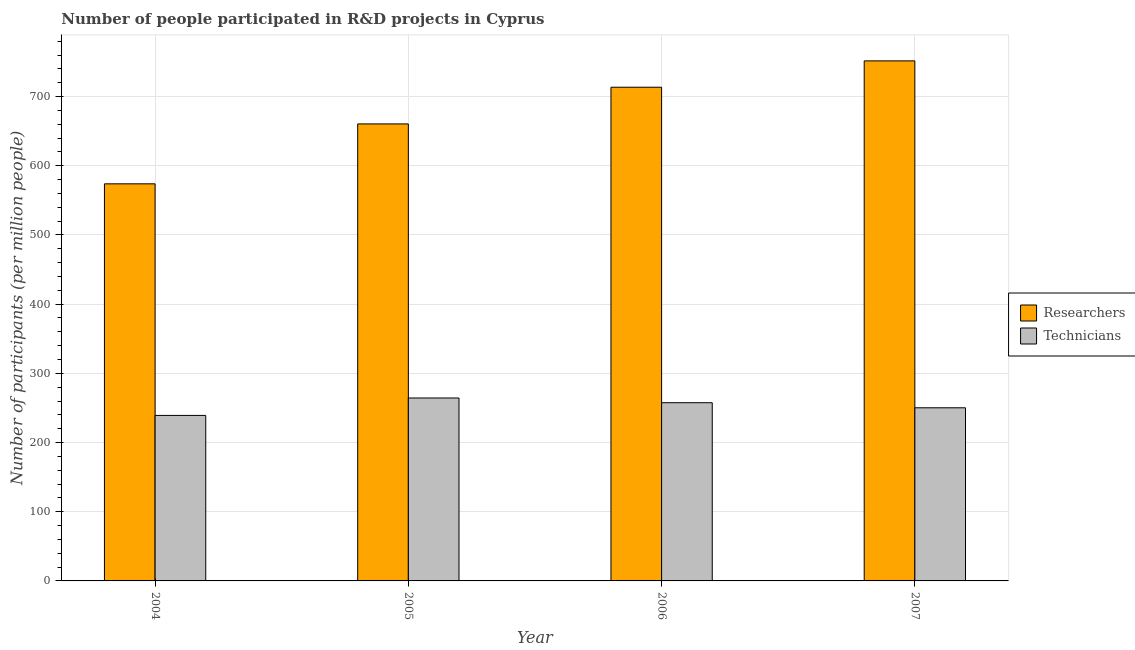How many groups of bars are there?
Give a very brief answer. 4. Are the number of bars on each tick of the X-axis equal?
Ensure brevity in your answer.  Yes. How many bars are there on the 2nd tick from the left?
Offer a very short reply. 2. How many bars are there on the 3rd tick from the right?
Offer a very short reply. 2. What is the number of researchers in 2006?
Offer a terse response. 713.54. Across all years, what is the maximum number of researchers?
Your answer should be compact. 751.62. Across all years, what is the minimum number of technicians?
Your answer should be compact. 239.21. In which year was the number of researchers maximum?
Offer a terse response. 2007. In which year was the number of researchers minimum?
Make the answer very short. 2004. What is the total number of researchers in the graph?
Make the answer very short. 2699.55. What is the difference between the number of technicians in 2004 and that in 2005?
Provide a succinct answer. -25.17. What is the difference between the number of technicians in 2005 and the number of researchers in 2007?
Give a very brief answer. 14.16. What is the average number of technicians per year?
Give a very brief answer. 252.85. What is the ratio of the number of technicians in 2006 to that in 2007?
Your answer should be very brief. 1.03. Is the difference between the number of technicians in 2005 and 2006 greater than the difference between the number of researchers in 2005 and 2006?
Provide a short and direct response. No. What is the difference between the highest and the second highest number of technicians?
Provide a succinct answer. 6.82. What is the difference between the highest and the lowest number of technicians?
Make the answer very short. 25.17. In how many years, is the number of technicians greater than the average number of technicians taken over all years?
Provide a succinct answer. 2. What does the 1st bar from the left in 2005 represents?
Give a very brief answer. Researchers. What does the 2nd bar from the right in 2005 represents?
Your answer should be compact. Researchers. Are the values on the major ticks of Y-axis written in scientific E-notation?
Keep it short and to the point. No. Does the graph contain any zero values?
Your response must be concise. No. Does the graph contain grids?
Make the answer very short. Yes. How many legend labels are there?
Your response must be concise. 2. What is the title of the graph?
Your answer should be compact. Number of people participated in R&D projects in Cyprus. Does "Register a property" appear as one of the legend labels in the graph?
Offer a very short reply. No. What is the label or title of the X-axis?
Offer a very short reply. Year. What is the label or title of the Y-axis?
Make the answer very short. Number of participants (per million people). What is the Number of participants (per million people) in Researchers in 2004?
Provide a succinct answer. 573.92. What is the Number of participants (per million people) in Technicians in 2004?
Keep it short and to the point. 239.21. What is the Number of participants (per million people) of Researchers in 2005?
Provide a succinct answer. 660.48. What is the Number of participants (per million people) in Technicians in 2005?
Give a very brief answer. 264.38. What is the Number of participants (per million people) in Researchers in 2006?
Your response must be concise. 713.54. What is the Number of participants (per million people) in Technicians in 2006?
Provide a short and direct response. 257.56. What is the Number of participants (per million people) of Researchers in 2007?
Make the answer very short. 751.62. What is the Number of participants (per million people) of Technicians in 2007?
Your answer should be very brief. 250.23. Across all years, what is the maximum Number of participants (per million people) of Researchers?
Ensure brevity in your answer.  751.62. Across all years, what is the maximum Number of participants (per million people) in Technicians?
Offer a terse response. 264.38. Across all years, what is the minimum Number of participants (per million people) of Researchers?
Provide a short and direct response. 573.92. Across all years, what is the minimum Number of participants (per million people) of Technicians?
Offer a terse response. 239.21. What is the total Number of participants (per million people) of Researchers in the graph?
Provide a succinct answer. 2699.55. What is the total Number of participants (per million people) in Technicians in the graph?
Ensure brevity in your answer.  1011.39. What is the difference between the Number of participants (per million people) of Researchers in 2004 and that in 2005?
Your response must be concise. -86.56. What is the difference between the Number of participants (per million people) in Technicians in 2004 and that in 2005?
Give a very brief answer. -25.17. What is the difference between the Number of participants (per million people) in Researchers in 2004 and that in 2006?
Your answer should be very brief. -139.62. What is the difference between the Number of participants (per million people) in Technicians in 2004 and that in 2006?
Keep it short and to the point. -18.35. What is the difference between the Number of participants (per million people) in Researchers in 2004 and that in 2007?
Offer a terse response. -177.7. What is the difference between the Number of participants (per million people) in Technicians in 2004 and that in 2007?
Offer a terse response. -11.01. What is the difference between the Number of participants (per million people) of Researchers in 2005 and that in 2006?
Your response must be concise. -53.06. What is the difference between the Number of participants (per million people) of Technicians in 2005 and that in 2006?
Provide a succinct answer. 6.82. What is the difference between the Number of participants (per million people) in Researchers in 2005 and that in 2007?
Offer a terse response. -91.14. What is the difference between the Number of participants (per million people) in Technicians in 2005 and that in 2007?
Your answer should be compact. 14.16. What is the difference between the Number of participants (per million people) in Researchers in 2006 and that in 2007?
Your answer should be very brief. -38.08. What is the difference between the Number of participants (per million people) of Technicians in 2006 and that in 2007?
Your answer should be compact. 7.34. What is the difference between the Number of participants (per million people) in Researchers in 2004 and the Number of participants (per million people) in Technicians in 2005?
Keep it short and to the point. 309.53. What is the difference between the Number of participants (per million people) in Researchers in 2004 and the Number of participants (per million people) in Technicians in 2006?
Your response must be concise. 316.36. What is the difference between the Number of participants (per million people) in Researchers in 2004 and the Number of participants (per million people) in Technicians in 2007?
Your response must be concise. 323.69. What is the difference between the Number of participants (per million people) in Researchers in 2005 and the Number of participants (per million people) in Technicians in 2006?
Ensure brevity in your answer.  402.92. What is the difference between the Number of participants (per million people) in Researchers in 2005 and the Number of participants (per million people) in Technicians in 2007?
Your answer should be compact. 410.25. What is the difference between the Number of participants (per million people) of Researchers in 2006 and the Number of participants (per million people) of Technicians in 2007?
Provide a short and direct response. 463.32. What is the average Number of participants (per million people) of Researchers per year?
Provide a short and direct response. 674.89. What is the average Number of participants (per million people) in Technicians per year?
Your answer should be very brief. 252.85. In the year 2004, what is the difference between the Number of participants (per million people) of Researchers and Number of participants (per million people) of Technicians?
Offer a terse response. 334.7. In the year 2005, what is the difference between the Number of participants (per million people) in Researchers and Number of participants (per million people) in Technicians?
Ensure brevity in your answer.  396.09. In the year 2006, what is the difference between the Number of participants (per million people) in Researchers and Number of participants (per million people) in Technicians?
Your answer should be compact. 455.98. In the year 2007, what is the difference between the Number of participants (per million people) of Researchers and Number of participants (per million people) of Technicians?
Offer a very short reply. 501.39. What is the ratio of the Number of participants (per million people) in Researchers in 2004 to that in 2005?
Offer a very short reply. 0.87. What is the ratio of the Number of participants (per million people) in Technicians in 2004 to that in 2005?
Make the answer very short. 0.9. What is the ratio of the Number of participants (per million people) in Researchers in 2004 to that in 2006?
Ensure brevity in your answer.  0.8. What is the ratio of the Number of participants (per million people) in Technicians in 2004 to that in 2006?
Provide a short and direct response. 0.93. What is the ratio of the Number of participants (per million people) of Researchers in 2004 to that in 2007?
Keep it short and to the point. 0.76. What is the ratio of the Number of participants (per million people) of Technicians in 2004 to that in 2007?
Keep it short and to the point. 0.96. What is the ratio of the Number of participants (per million people) in Researchers in 2005 to that in 2006?
Your answer should be very brief. 0.93. What is the ratio of the Number of participants (per million people) in Technicians in 2005 to that in 2006?
Provide a succinct answer. 1.03. What is the ratio of the Number of participants (per million people) in Researchers in 2005 to that in 2007?
Ensure brevity in your answer.  0.88. What is the ratio of the Number of participants (per million people) of Technicians in 2005 to that in 2007?
Give a very brief answer. 1.06. What is the ratio of the Number of participants (per million people) of Researchers in 2006 to that in 2007?
Give a very brief answer. 0.95. What is the ratio of the Number of participants (per million people) in Technicians in 2006 to that in 2007?
Offer a very short reply. 1.03. What is the difference between the highest and the second highest Number of participants (per million people) of Researchers?
Give a very brief answer. 38.08. What is the difference between the highest and the second highest Number of participants (per million people) in Technicians?
Give a very brief answer. 6.82. What is the difference between the highest and the lowest Number of participants (per million people) of Researchers?
Offer a very short reply. 177.7. What is the difference between the highest and the lowest Number of participants (per million people) in Technicians?
Keep it short and to the point. 25.17. 